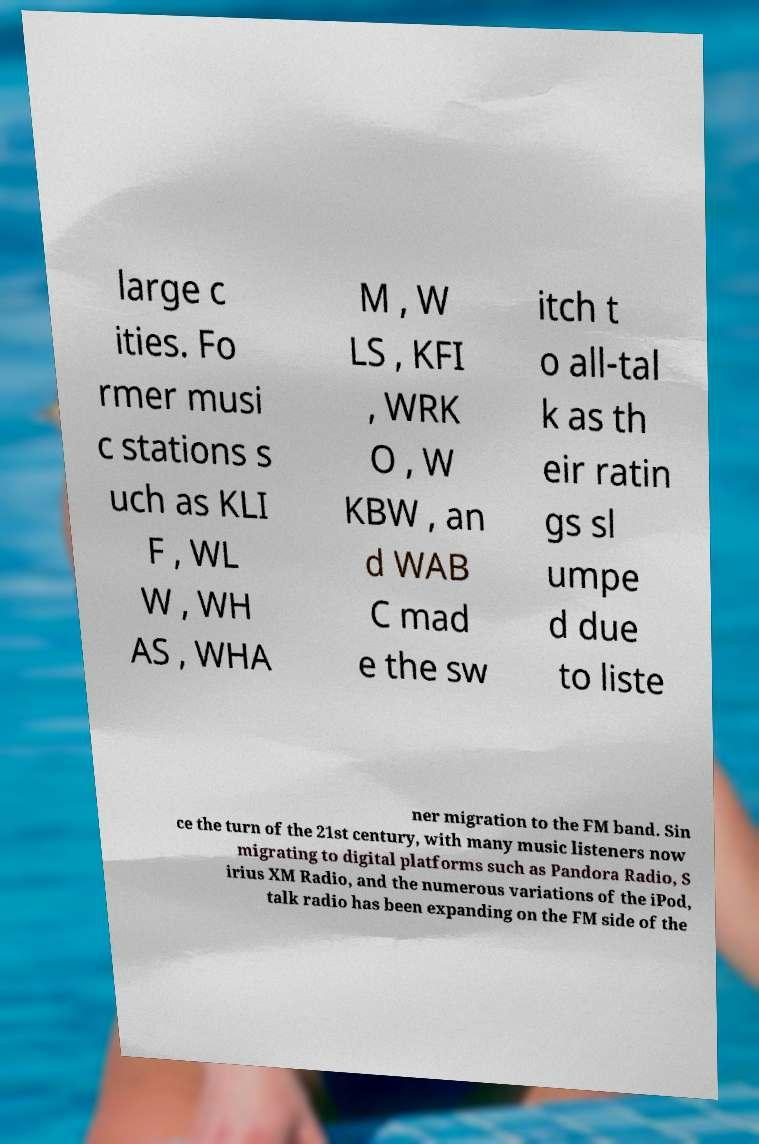What messages or text are displayed in this image? I need them in a readable, typed format. large c ities. Fo rmer musi c stations s uch as KLI F , WL W , WH AS , WHA M , W LS , KFI , WRK O , W KBW , an d WAB C mad e the sw itch t o all-tal k as th eir ratin gs sl umpe d due to liste ner migration to the FM band. Sin ce the turn of the 21st century, with many music listeners now migrating to digital platforms such as Pandora Radio, S irius XM Radio, and the numerous variations of the iPod, talk radio has been expanding on the FM side of the 